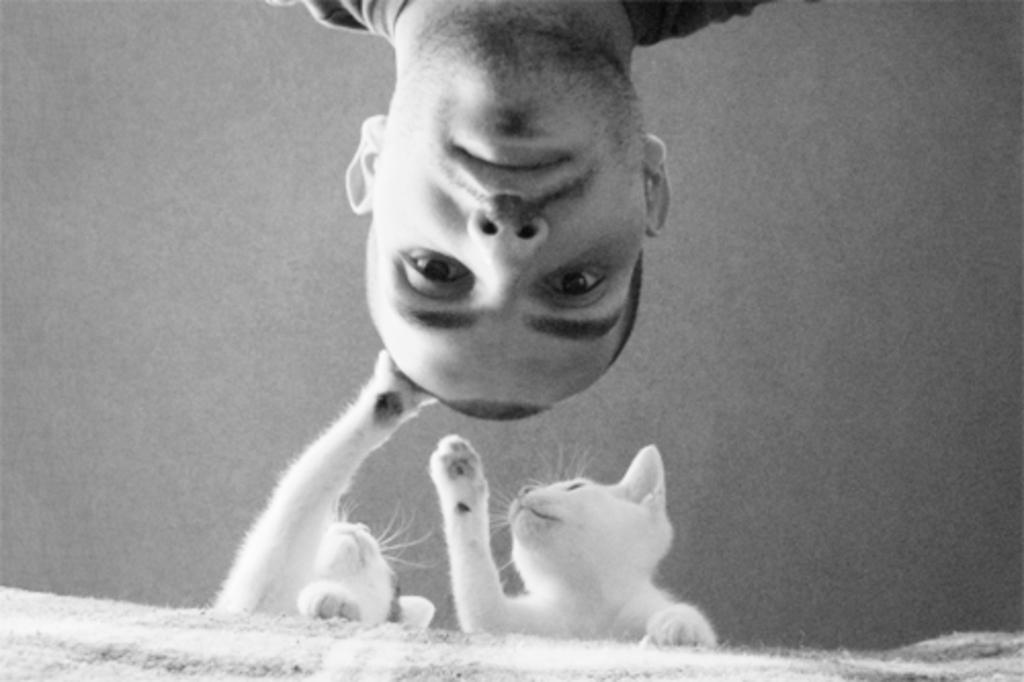Who is present in the image? There is a man in the image. What is the man wearing? The man is wearing a t-shirt. What animals can be seen in the image? There are two white cats in the image. Where are the cats located in the image? The cats are standing near a bed. What is the gravitational attraction between the two cats in the image? There is no information about gravitational attraction in the image, as it focuses on the man and the cats' location. 